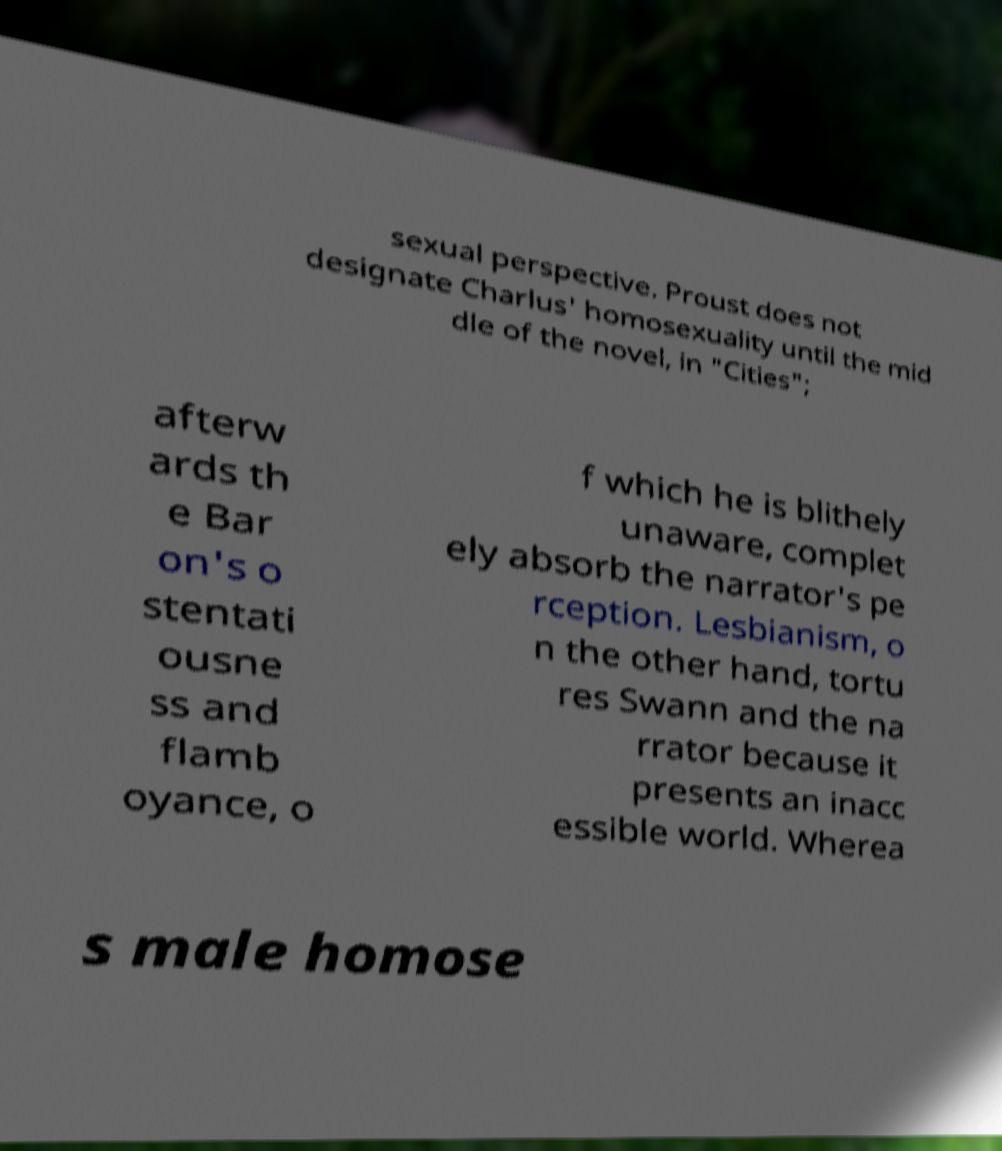Can you read and provide the text displayed in the image?This photo seems to have some interesting text. Can you extract and type it out for me? sexual perspective. Proust does not designate Charlus' homosexuality until the mid dle of the novel, in "Cities"; afterw ards th e Bar on's o stentati ousne ss and flamb oyance, o f which he is blithely unaware, complet ely absorb the narrator's pe rception. Lesbianism, o n the other hand, tortu res Swann and the na rrator because it presents an inacc essible world. Wherea s male homose 